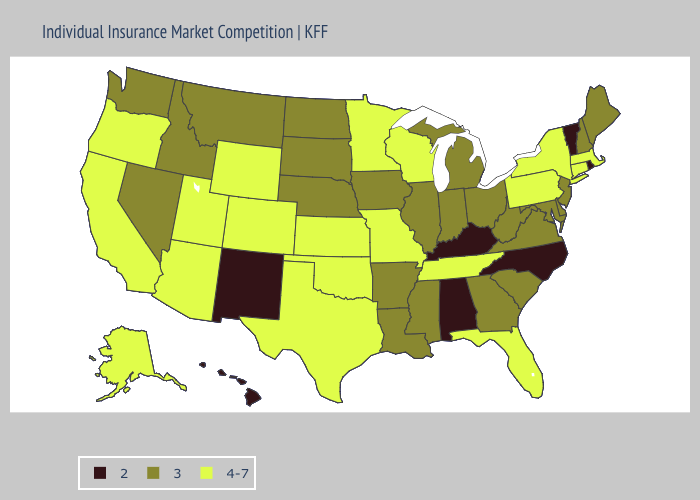Name the states that have a value in the range 4-7?
Keep it brief. Alaska, Arizona, California, Colorado, Connecticut, Florida, Kansas, Massachusetts, Minnesota, Missouri, New York, Oklahoma, Oregon, Pennsylvania, Tennessee, Texas, Utah, Wisconsin, Wyoming. Does New Mexico have the lowest value in the USA?
Write a very short answer. Yes. Among the states that border New Hampshire , does Vermont have the highest value?
Give a very brief answer. No. Among the states that border New York , which have the lowest value?
Concise answer only. Vermont. Among the states that border Alabama , which have the lowest value?
Write a very short answer. Georgia, Mississippi. What is the lowest value in the MidWest?
Be succinct. 3. Name the states that have a value in the range 4-7?
Quick response, please. Alaska, Arizona, California, Colorado, Connecticut, Florida, Kansas, Massachusetts, Minnesota, Missouri, New York, Oklahoma, Oregon, Pennsylvania, Tennessee, Texas, Utah, Wisconsin, Wyoming. Does New Jersey have the lowest value in the Northeast?
Answer briefly. No. Name the states that have a value in the range 3?
Quick response, please. Arkansas, Delaware, Georgia, Idaho, Illinois, Indiana, Iowa, Louisiana, Maine, Maryland, Michigan, Mississippi, Montana, Nebraska, Nevada, New Hampshire, New Jersey, North Dakota, Ohio, South Carolina, South Dakota, Virginia, Washington, West Virginia. What is the value of Rhode Island?
Concise answer only. 2. What is the highest value in states that border Indiana?
Keep it brief. 3. Name the states that have a value in the range 4-7?
Short answer required. Alaska, Arizona, California, Colorado, Connecticut, Florida, Kansas, Massachusetts, Minnesota, Missouri, New York, Oklahoma, Oregon, Pennsylvania, Tennessee, Texas, Utah, Wisconsin, Wyoming. Which states have the highest value in the USA?
Keep it brief. Alaska, Arizona, California, Colorado, Connecticut, Florida, Kansas, Massachusetts, Minnesota, Missouri, New York, Oklahoma, Oregon, Pennsylvania, Tennessee, Texas, Utah, Wisconsin, Wyoming. What is the highest value in states that border Connecticut?
Be succinct. 4-7. Which states hav the highest value in the South?
Short answer required. Florida, Oklahoma, Tennessee, Texas. 